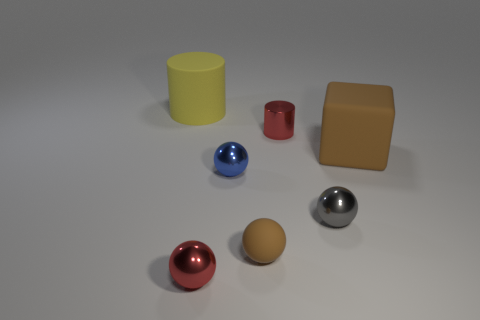Subtract all gray balls. How many balls are left? 3 Subtract all rubber balls. How many balls are left? 3 Subtract 1 balls. How many balls are left? 3 Subtract all green balls. Subtract all cyan cylinders. How many balls are left? 4 Add 1 tiny blocks. How many objects exist? 8 Subtract all balls. How many objects are left? 3 Subtract 0 green cubes. How many objects are left? 7 Subtract all tiny gray spheres. Subtract all tiny brown balls. How many objects are left? 5 Add 4 small matte objects. How many small matte objects are left? 5 Add 5 red objects. How many red objects exist? 7 